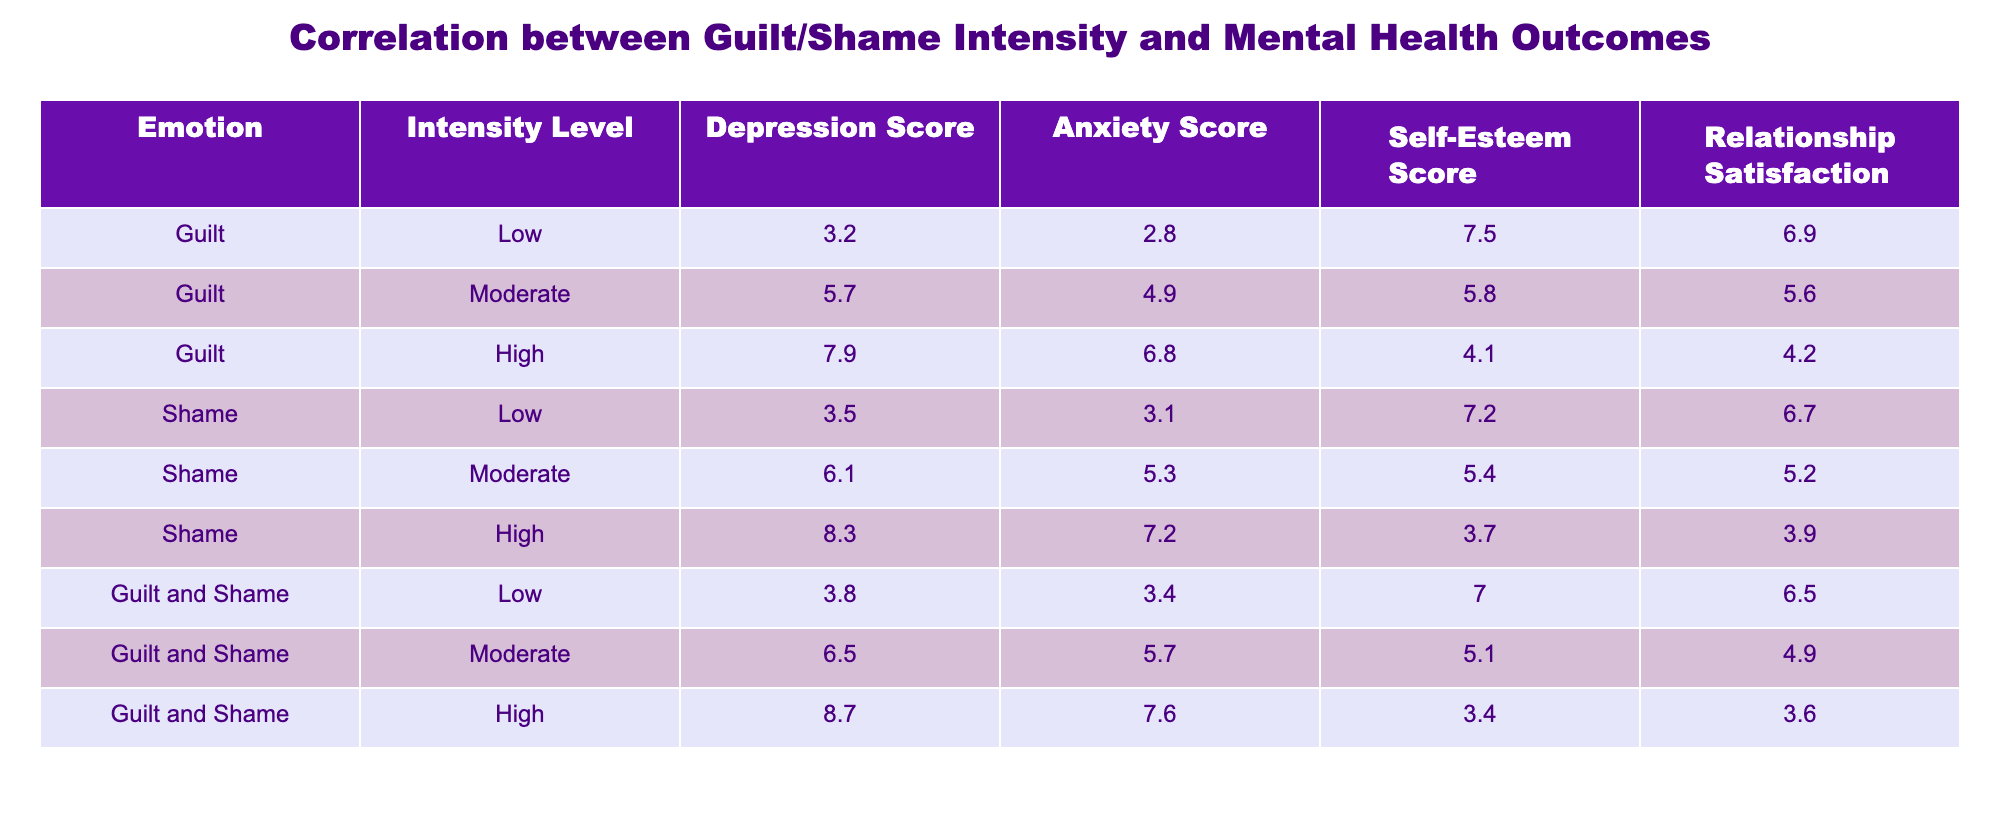What is the Depression Score for individuals experiencing High Guilt? The table shows that for individuals experiencing High Guilt, the Depression Score is 7.9.
Answer: 7.9 What is the Anxiety Score for those who feel Low Shame? According to the table, the Anxiety Score for individuals feeling Low Shame is 3.1.
Answer: 3.1 Which emotion, Guilt or Shame, has the highest Self-Esteem Score at the Moderate Intensity Level? The Self-Esteem Score at the Moderate Intensity Level is 5.8 for Guilt and 5.4 for Shame. Comparing these two shows that Guilt has a higher score.
Answer: Guilt What is the average Relationship Satisfaction for individuals experiencing High levels of both Guilt and Shame? For both Guilt and Shame at High levels, the Relationship Satisfaction is 4.2 and 3.9, respectively. To find the average: (4.2 + 3.9) / 2 = 4.05.
Answer: 4.05 Is it true that individuals feeling Moderate Guilt have a higher Depression Score than those feeling Moderate Shame? The Depression Scores are 5.7 for Moderate Guilt and 6.1 for Moderate Shame. Therefore, the statement is false as Moderate Shame has a higher score.
Answer: No What is the difference in Anxiety Scores between individuals experiencing Low Guilt and those experiencing Low Shame? The Anxiety Score for Low Guilt is 2.8 and for Low Shame it is 3.1. To find the difference: 3.1 - 2.8 = 0.3.
Answer: 0.3 What is the Self-Esteem Score for individuals with High levels of Guilt and Shame compared to those with Low levels? For High levels, the Self-Esteem Score is 3.4 for Guilt and Shame, while for Low levels it is 7.5 for Guilt and 7.2 for Shame. The Low levels (7.5 and 7.2) show a significant difference compared to the High levels (3.4).
Answer: 3.4 (High), 7.5 & 7.2 (Low) What is the relationship between Guilt and Shame Intensities and Depression Scores? The table indicates that as the Intensity levels increase for both Guilt and Shame, the Depression Scores also increase. For instance, High Guilt has a score of 7.9, while Low Guilt has 3.2.
Answer: Positive correlation What is the highest Anxiety Score recorded in the table? Reviewing the table shows that the highest Anxiety Score is 7.6 for individuals experiencing High levels of Guilt and Shame.
Answer: 7.6 